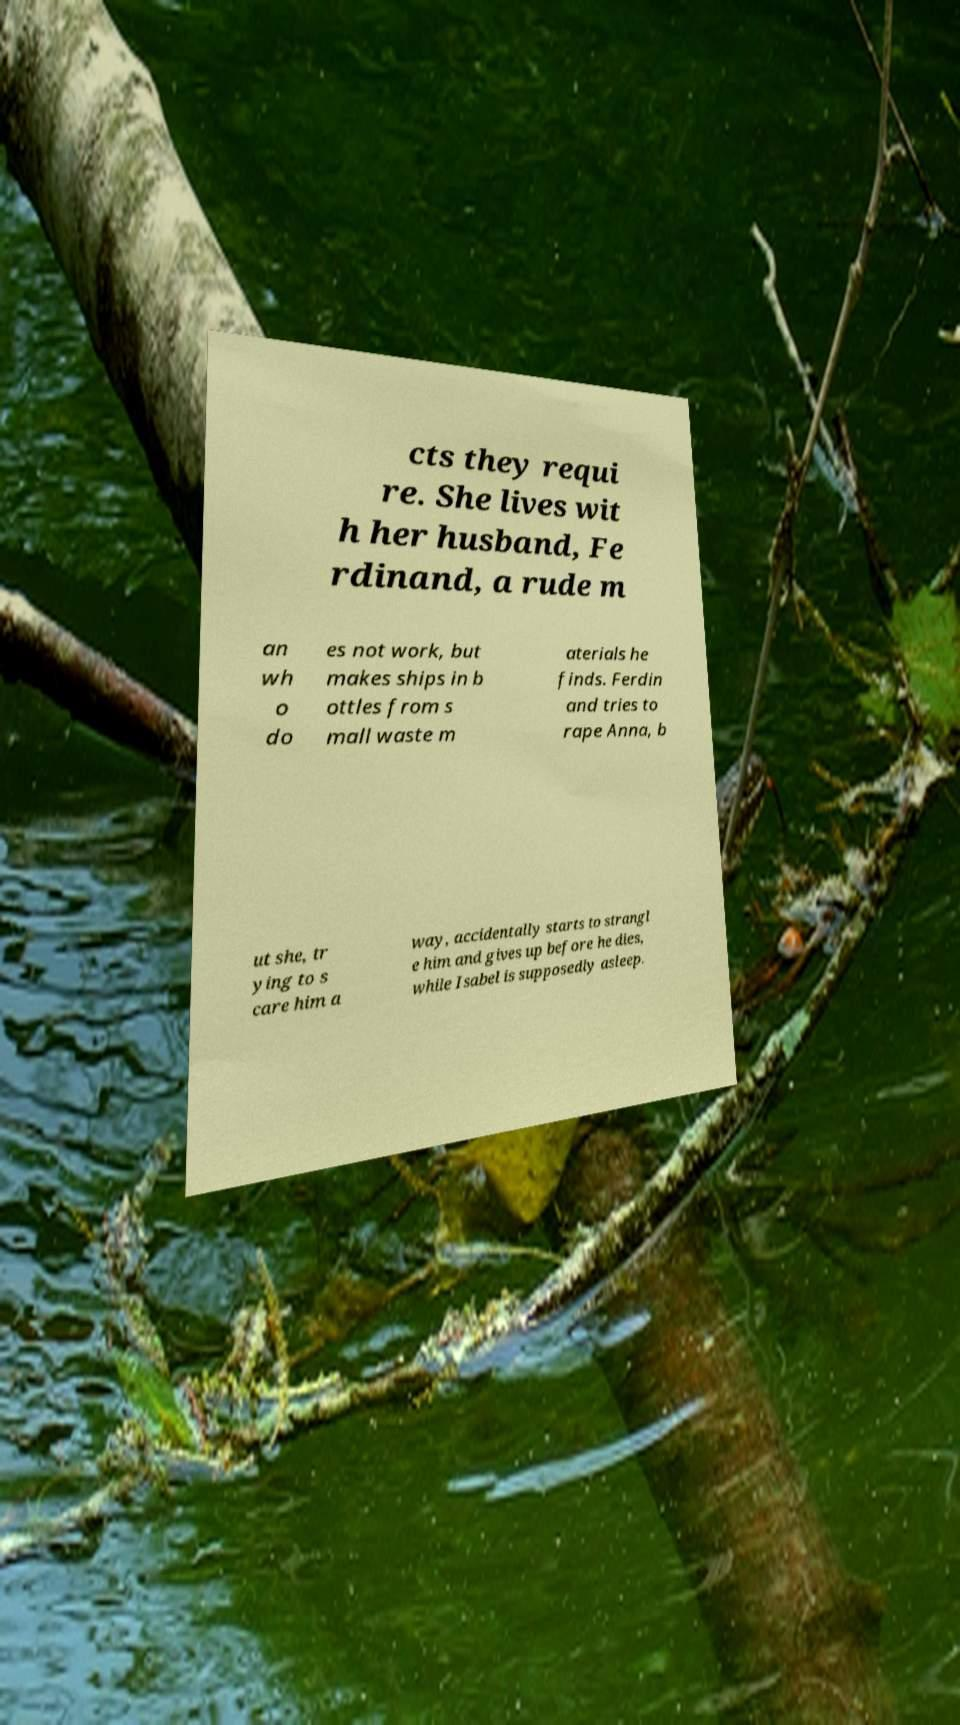Could you assist in decoding the text presented in this image and type it out clearly? cts they requi re. She lives wit h her husband, Fe rdinand, a rude m an wh o do es not work, but makes ships in b ottles from s mall waste m aterials he finds. Ferdin and tries to rape Anna, b ut she, tr ying to s care him a way, accidentally starts to strangl e him and gives up before he dies, while Isabel is supposedly asleep. 